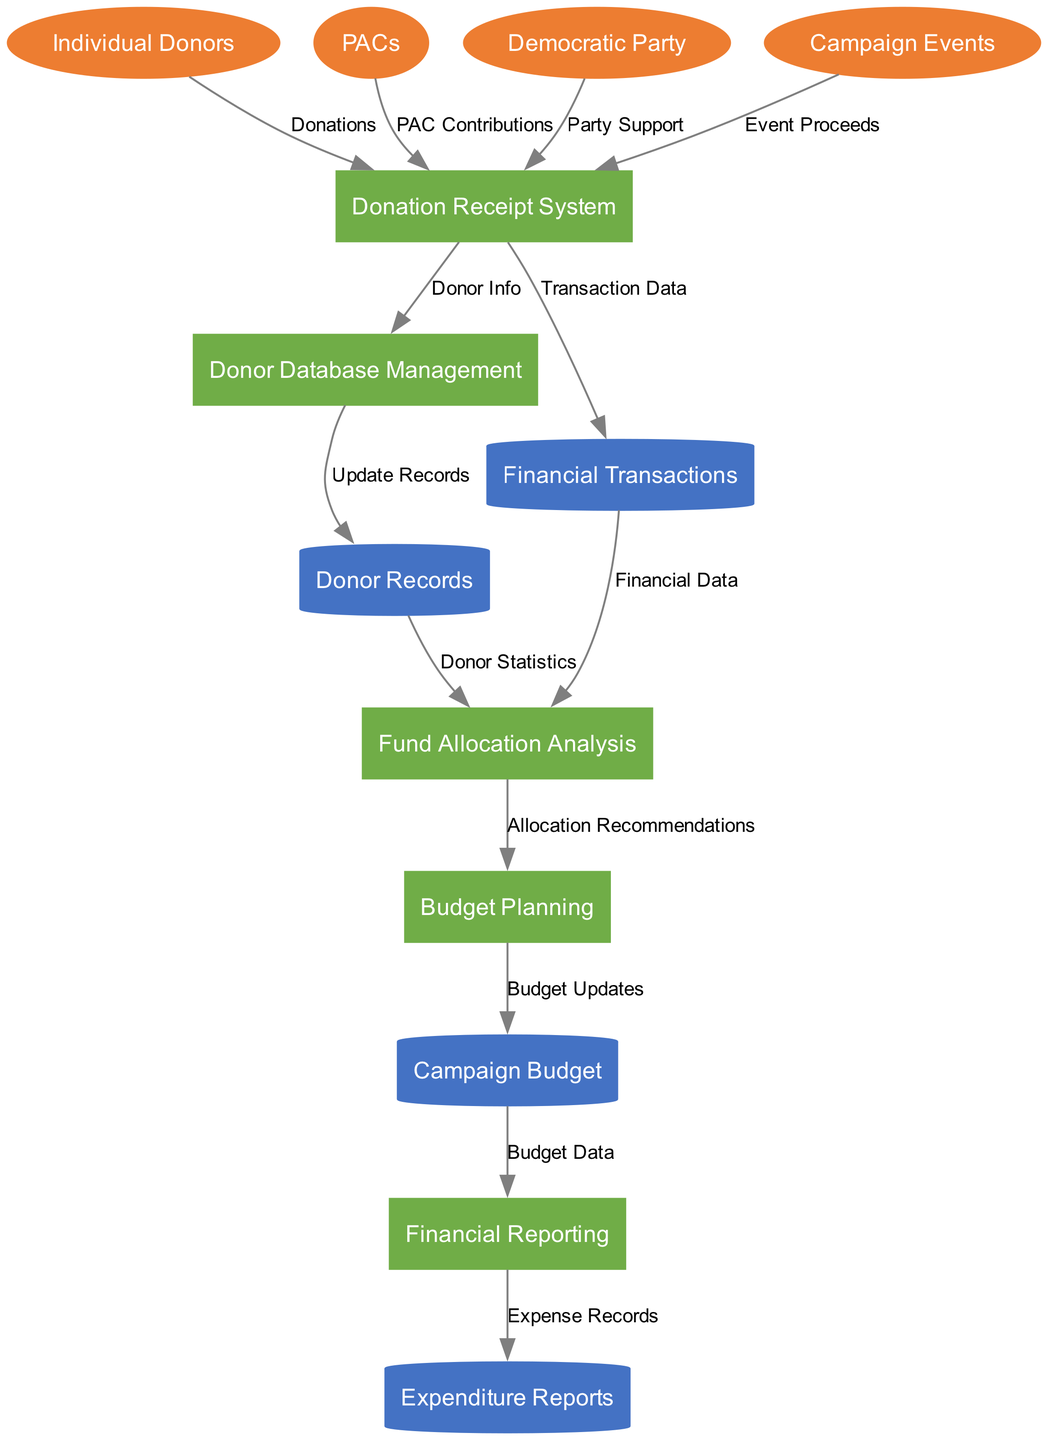What are the primary external entities in the diagram? The external entities represented in the diagram include Individual Donors, PACs, Democratic Party, and Campaign Events.
Answer: Individual Donors, PACs, Democratic Party, Campaign Events How many processes are defined in this fundraising system? The diagram lists five distinct processes: Donation Receipt System, Donor Database Management, Fund Allocation Analysis, Financial Reporting, and Budget Planning.
Answer: Five What data flows from the Donation Receipt System to the Donor Database Management? The flow from the Donation Receipt System to the Donor Database Management is labeled as Donor Info, indicating the information transferred regarding donors.
Answer: Donor Info Which data store receives data from Donor Database Management? Donor Database Management updates the Donor Records data store, allowing it to maintain current information on donors.
Answer: Donor Records What is the final output of the Financial Reporting process? The Financial Reporting process produces Expenditure Reports, which detail the expenses incurred by the campaign, signifying the completion of the financial reporting cycle.
Answer: Expenditure Reports What is the relationship between Fund Allocation Analysis and Budget Planning? Fund Allocation Analysis provides Allocation Recommendations to the Budget Planning process, indicating that the analysis influences the planning of the campaign budget.
Answer: Allocation Recommendations What type of contributions does the PACs entity provide to the Donation Receipt System? PACs provide PAC Contributions to the Donation Receipt System, which is a key input for raising funds for the campaign.
Answer: PAC Contributions How many data stores are represented in the diagram? The diagram contains four data stores, which are Donor Records, Financial Transactions, Campaign Budget, and Expenditure Reports.
Answer: Four 